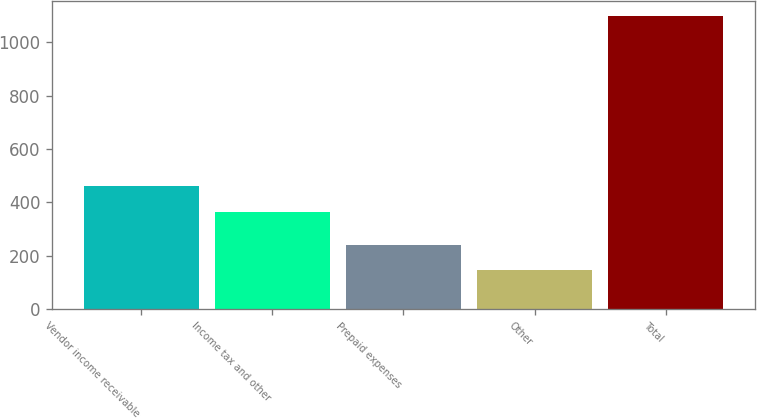Convert chart. <chart><loc_0><loc_0><loc_500><loc_500><bar_chart><fcel>Vendor income receivable<fcel>Income tax and other<fcel>Prepaid expenses<fcel>Other<fcel>Total<nl><fcel>459.6<fcel>364<fcel>239.6<fcel>144<fcel>1100<nl></chart> 